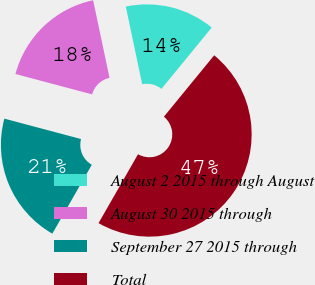Convert chart. <chart><loc_0><loc_0><loc_500><loc_500><pie_chart><fcel>August 2 2015 through August<fcel>August 30 2015 through<fcel>September 27 2015 through<fcel>Total<nl><fcel>14.24%<fcel>17.55%<fcel>20.86%<fcel>47.36%<nl></chart> 